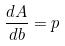<formula> <loc_0><loc_0><loc_500><loc_500>\frac { d A } { d b } = p</formula> 